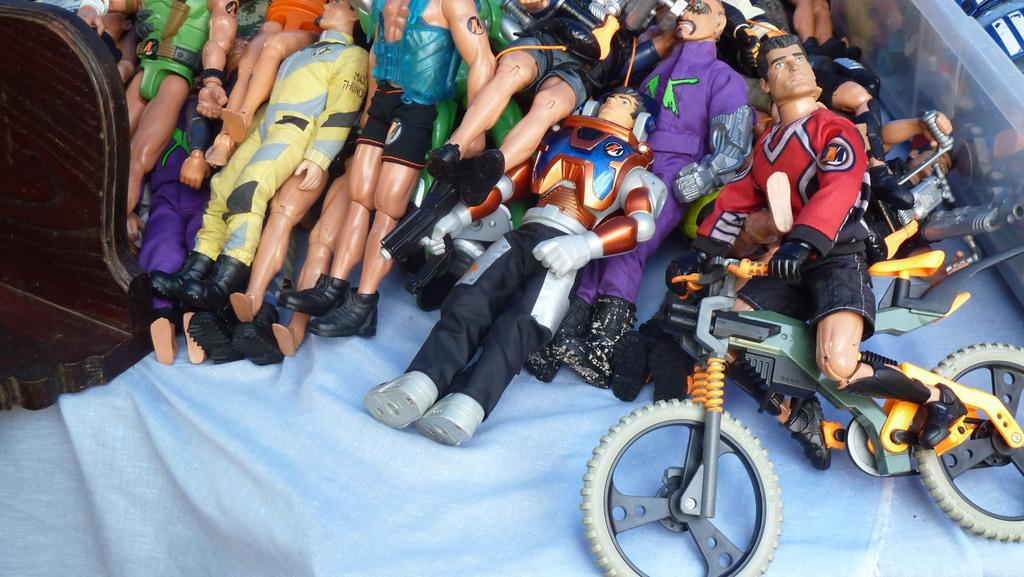What is placed on the cloth in the image? There are toys on a cloth in the image. Can you describe the object on the left side of the image? There is an object on the left side of the image, but its description is not provided in the facts. Can you describe the object on the right side of the image? There is an object on the right side of the image, but its description is not provided in the facts. How many rings are visible on the bridge in the image? There is no bridge or rings present in the image. What type of spark can be seen coming from the toys in the image? There is no spark visible in the image; the toys are not described as having any spark or special effect. 